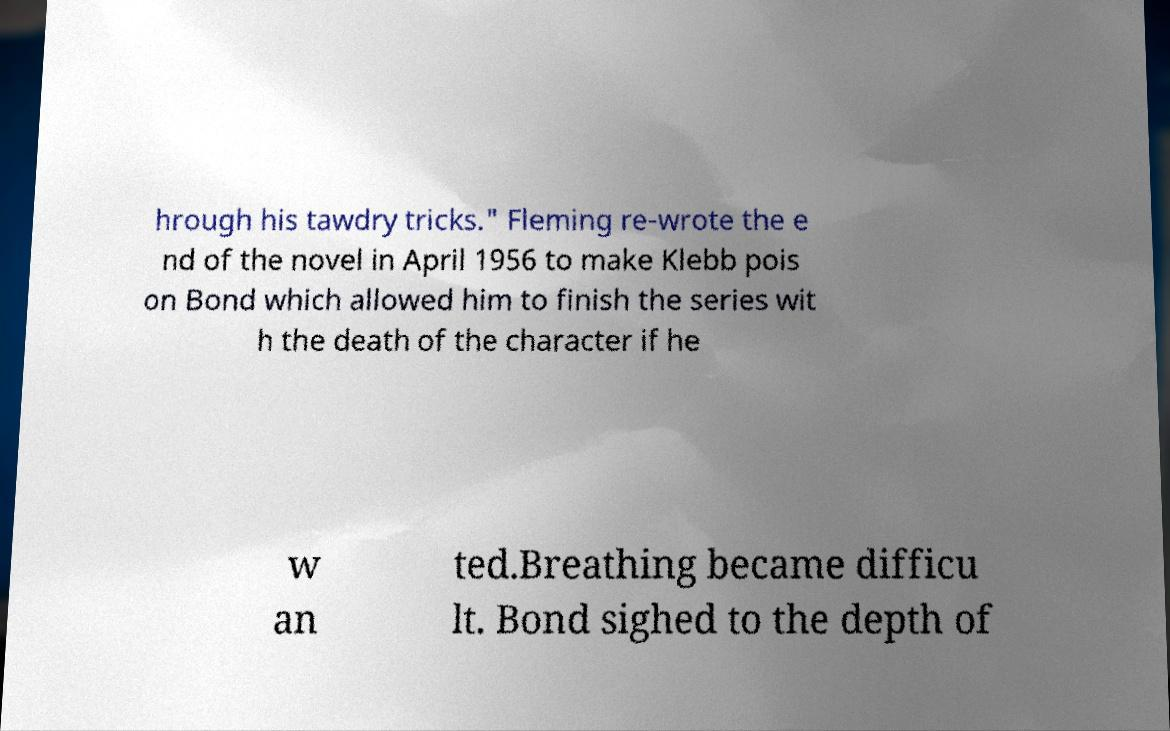Can you accurately transcribe the text from the provided image for me? hrough his tawdry tricks." Fleming re-wrote the e nd of the novel in April 1956 to make Klebb pois on Bond which allowed him to finish the series wit h the death of the character if he w an ted.Breathing became difficu lt. Bond sighed to the depth of 